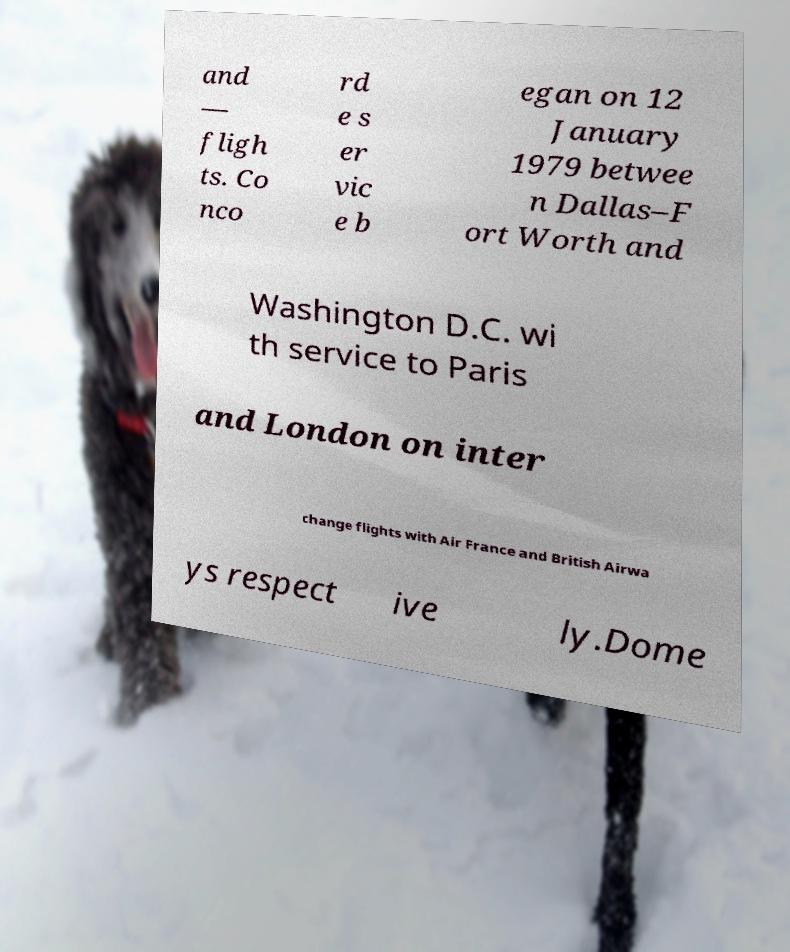I need the written content from this picture converted into text. Can you do that? and — fligh ts. Co nco rd e s er vic e b egan on 12 January 1979 betwee n Dallas–F ort Worth and Washington D.C. wi th service to Paris and London on inter change flights with Air France and British Airwa ys respect ive ly.Dome 